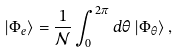Convert formula to latex. <formula><loc_0><loc_0><loc_500><loc_500>\left | \Phi _ { e } \right \rangle = \frac { 1 } { \mathcal { N } } \int _ { 0 } ^ { 2 \pi } d \theta \left | \Phi _ { \theta } \right \rangle ,</formula> 